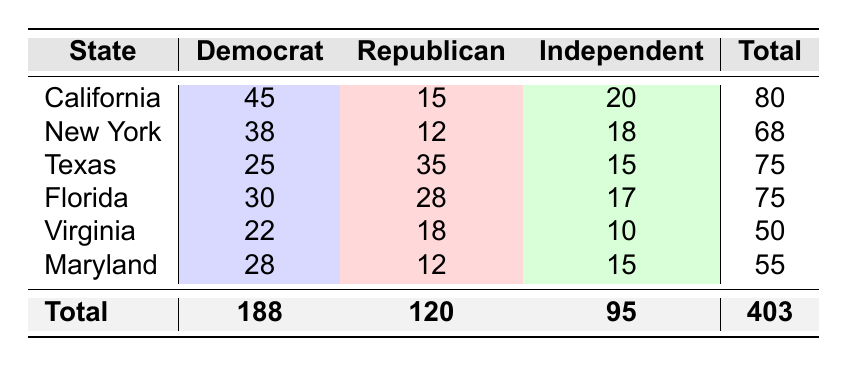What is the total number of Democrat students from California? The table shows that there are 45 Democrat students from California, which is directly stated in the corresponding cell under California's Democrat column.
Answer: 45 Which state has the highest number of Republican students? By comparing the Republican counts among all states, Texas has 35 Republican students, which is the highest number listed.
Answer: Texas What is the overall total number of Independent students from all states? To find the total number of Independent students, add the Independent counts from all states: 20 (California) + 18 (New York) + 15 (Texas) + 17 (Florida) + 10 (Virginia) + 15 (Maryland) = 95.
Answer: 95 How many more Democrat students are there in Florida compared to Virginia? From the table, Florida has 30 Democrat students and Virginia has 22. The difference is calculated by subtracting Virginia's count from Florida's: 30 - 22 = 8.
Answer: 8 What percentage of students from Texas are Democrats? To find the percentage of Democrat students in Texas, divide the number of Democrat students (25) by the total number of students in Texas (75), then multiply by 100: (25/75) * 100 = 33.33%.
Answer: 33.33% Is the number of Republican students from New York greater than the number of Independent students from Florida? The table shows 12 Republican students from New York and 17 Independent students from Florida. Since 12 is less than 17, the answer is no, indicating that Republican students in New York are not greater than Independent students in Florida.
Answer: No What is the average number of Democrat students across all states? The total number of Democrat students is 188. There are 6 states, so to find the average, divide the total by the number of states: 188/6 = 31.33.
Answer: 31.33 Which state has a total number of students equal to 75? By examining the total counts for each state, both Texas and Florida have a total of 75 students each.
Answer: Texas and Florida If you combined the numbers of Republican and Independent students in Maryland, how many students would that be? The table shows 12 Republican and 15 Independent students in Maryland. To combine them, simply add the two values: 12 + 15 = 27.
Answer: 27 Which political party has the most students across all states? Adding the total counts from the table, Democrats have 188, Republicans have 120, and Independents have 95. The highest count is for Democrats at 188.
Answer: Democrats What is the difference in the total number of students between California and Virginia? California has a total of 80 students and Virginia has 50. To find the difference, subtract Virginia's total from California's: 80 - 50 = 30.
Answer: 30 